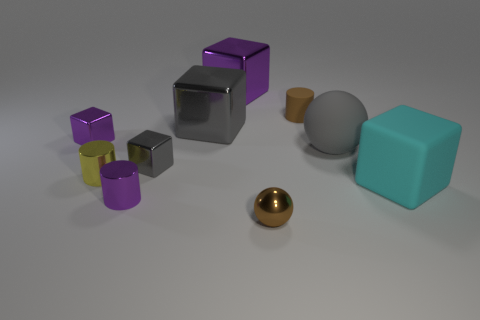Subtract all rubber blocks. How many blocks are left? 4 Subtract all cylinders. How many objects are left? 7 Subtract all yellow cylinders. How many cylinders are left? 2 Subtract 3 cylinders. How many cylinders are left? 0 Subtract all gray blocks. Subtract all red balls. How many blocks are left? 3 Subtract all green cylinders. How many gray spheres are left? 1 Subtract all large red matte objects. Subtract all brown cylinders. How many objects are left? 9 Add 7 tiny brown objects. How many tiny brown objects are left? 9 Add 8 tiny yellow metallic things. How many tiny yellow metallic things exist? 9 Subtract 0 blue cylinders. How many objects are left? 10 